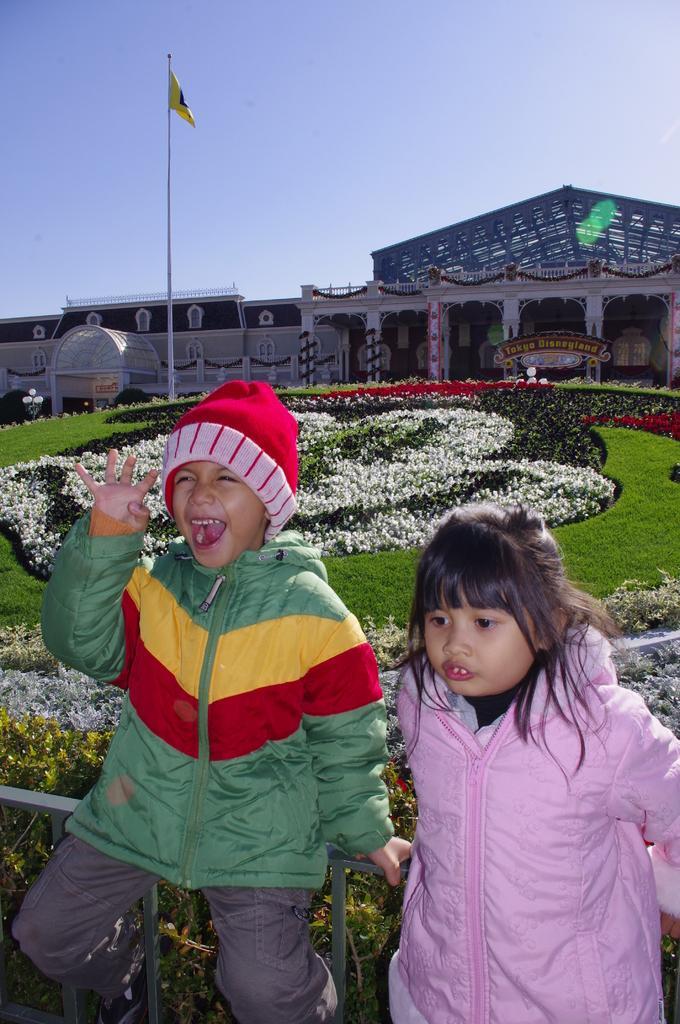Could you give a brief overview of what you see in this image? In this image I can see two people with different color dresses. I can see one person with the cap. In the back I can see the grass and there are some white flowers can be seen. In the background I can see the flag pole, building and the sky. 